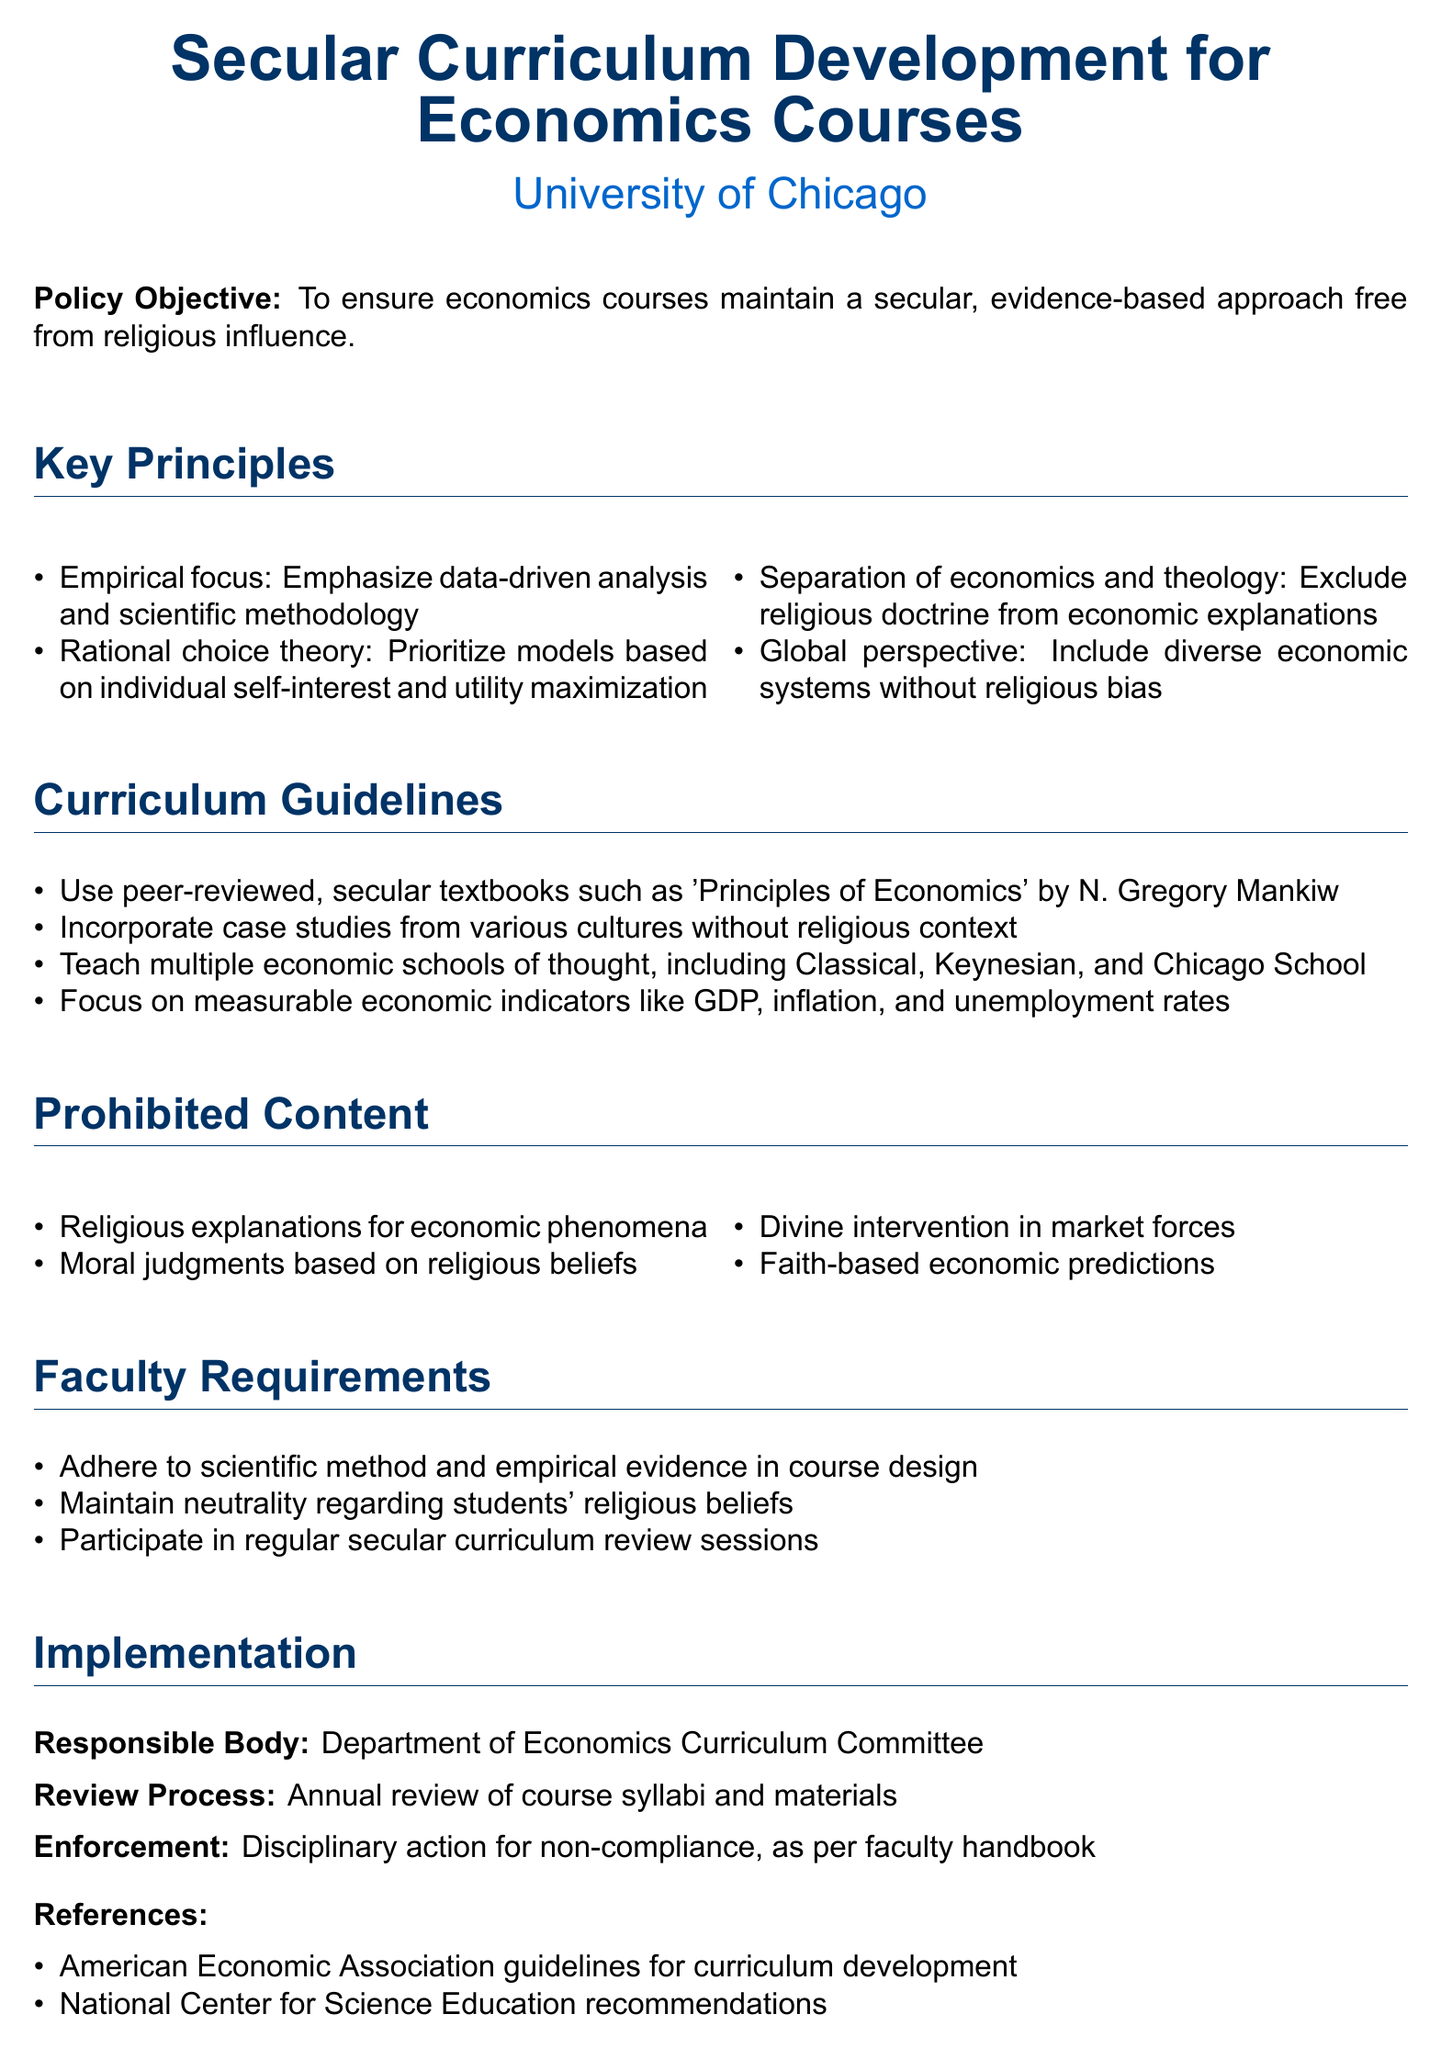What is the policy objective? The policy objective outlines the purpose of the document, which is to ensure a secular, evidence-based approach free from religious influence in economics courses.
Answer: To ensure economics courses maintain a secular, evidence-based approach free from religious influence What is one key principle of the curriculum? A key principle emphasizes the focus on empirical data and scientific methodology in course content.
Answer: Empirical focus What is prohibited content related to economic phenomena? The document specifies that religious explanations for economic phenomena should not be included in the curriculum.
Answer: Religious explanations for economic phenomena Who is responsible for implementing the policy? The document names a specific body responsible for the policy's implementation in economics courses.
Answer: Department of Economics Curriculum Committee What type of textbooks should be used? The guidelines specify the use of peer-reviewed, secular textbooks for course material.
Answer: Secular textbooks How often will the course syllabi be reviewed? The document states that there will be an annual review of the course syllabi and materials as part of the implementation process.
Answer: Annual review What must faculty maintain regarding students' beliefs? Faculty members are required to uphold a specific attitude towards the religious beliefs of students, as stated in the faculty requirements.
Answer: Neutrality regarding students' religious beliefs Which economic schools of thought should be taught? The curriculum guidelines indicate the inclusion of various economic schools that should be part of the teaching material.
Answer: Classical, Keynesian, and Chicago School 